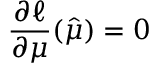Convert formula to latex. <formula><loc_0><loc_0><loc_500><loc_500>\frac { \partial \ell } { \partial \mu } ( \hat { \mu } ) = 0</formula> 